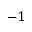Convert formula to latex. <formula><loc_0><loc_0><loc_500><loc_500>^ { - 1 }</formula> 